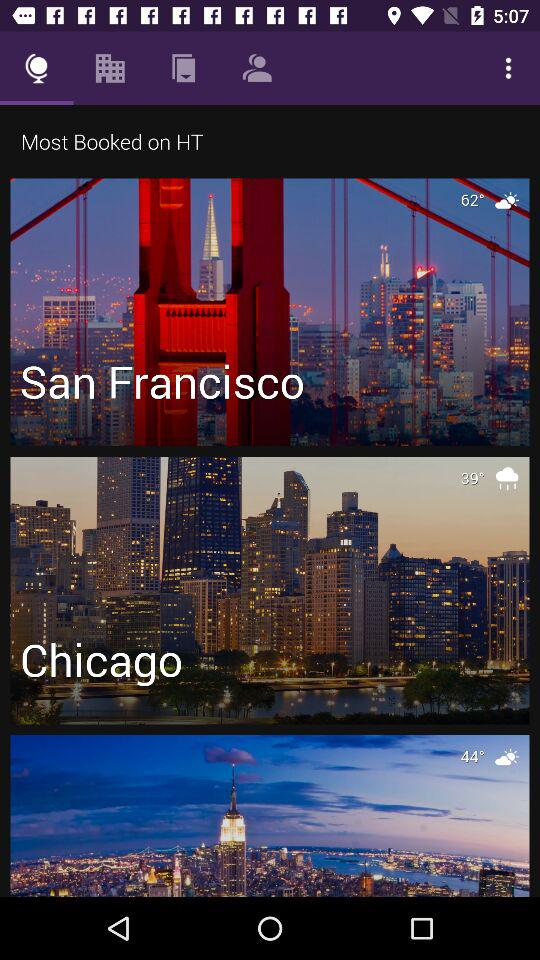How many more degrees is the temperature in San Francisco than Chicago?
Answer the question using a single word or phrase. 23 